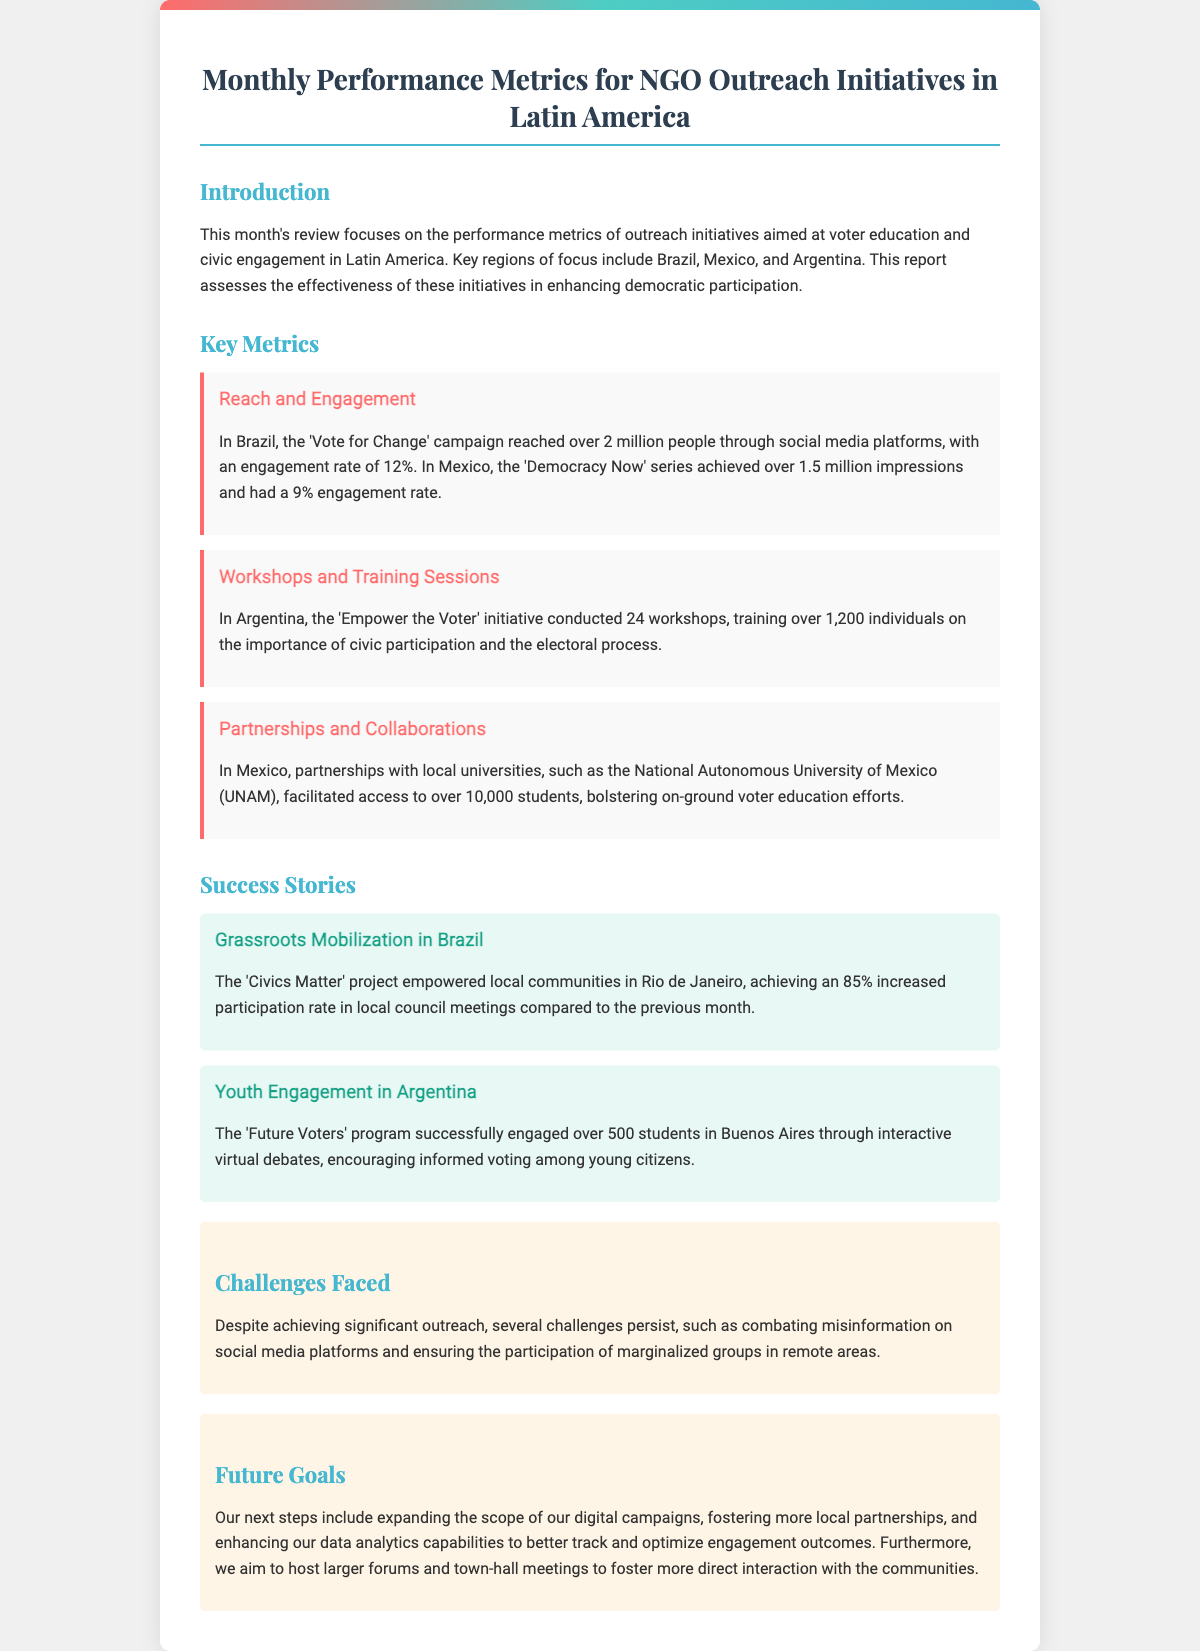What was the engagement rate of the 'Vote for Change' campaign in Brazil? The engagement rate is mentioned in the "Reach and Engagement" section of the document.
Answer: 12% How many workshops did the 'Empower the Voter' initiative conduct in Argentina? This information is provided in the "Workshops and Training Sessions" section.
Answer: 24 What type of program was the 'Future Voters' in Argentina? The description of the program is found within the "Success Stories" section.
Answer: Youth Engagement How many people were reached by the 'Democracy Now' series in Mexico? This number can be found in the "Reach and Engagement" section under Mexico's initiatives.
Answer: 1.5 million What percentage of increased participation was achieved in local council meetings in Brazil? The increased participation rate is specified in the "Success Stories" section regarding the 'Civics Matter' project.
Answer: 85% What are the identified challenges mentioned in the document? The "Challenges Faced" section outlines ongoing issues within outreach efforts.
Answer: Misinformation and Marginalization What is one of the future goals stated in the document? Future goals are detailed in the "Future Goals" section, listing initiatives to enhance outreach.
Answer: Expand digital campaigns Which region had partnerships with local universities for voter education programs? The collaboration details are specified in the "Partnerships and Collaborations" section.
Answer: Mexico 